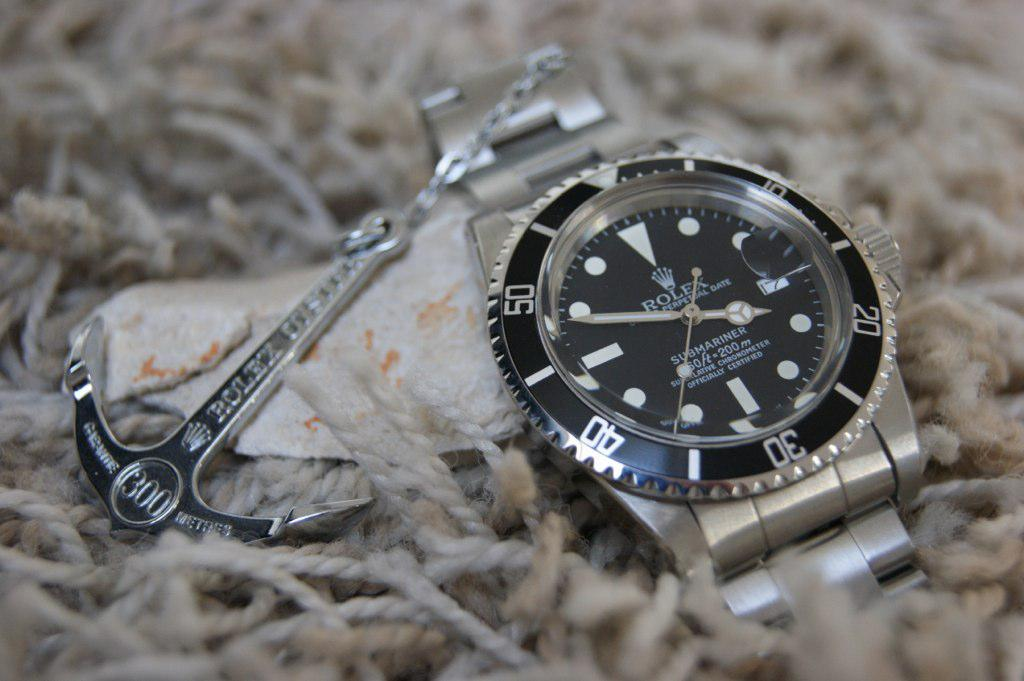<image>
Create a compact narrative representing the image presented. A Rolex watch has a decorative anchor attached to it. 